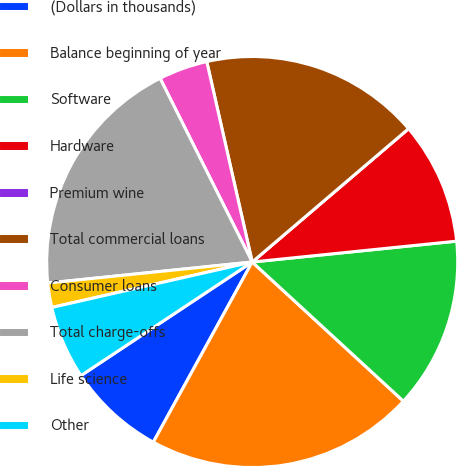Convert chart. <chart><loc_0><loc_0><loc_500><loc_500><pie_chart><fcel>(Dollars in thousands)<fcel>Balance beginning of year<fcel>Software<fcel>Hardware<fcel>Premium wine<fcel>Total commercial loans<fcel>Consumer loans<fcel>Total charge-offs<fcel>Life science<fcel>Other<nl><fcel>7.69%<fcel>21.15%<fcel>13.46%<fcel>9.62%<fcel>0.0%<fcel>17.31%<fcel>3.85%<fcel>19.23%<fcel>1.92%<fcel>5.77%<nl></chart> 